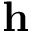<formula> <loc_0><loc_0><loc_500><loc_500>h</formula> 